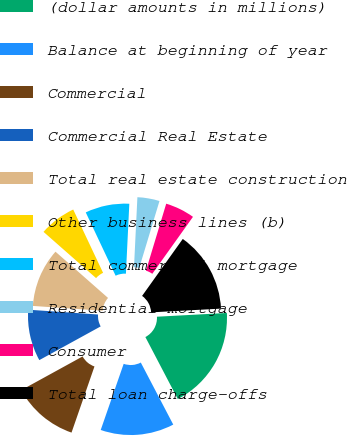Convert chart to OTSL. <chart><loc_0><loc_0><loc_500><loc_500><pie_chart><fcel>(dollar amounts in millions)<fcel>Balance at beginning of year<fcel>Commercial<fcel>Commercial Real Estate<fcel>Total real estate construction<fcel>Other business lines (b)<fcel>Total commercial mortgage<fcel>Residential mortgage<fcel>Consumer<fcel>Total loan charge-offs<nl><fcel>18.18%<fcel>12.99%<fcel>11.69%<fcel>9.09%<fcel>10.39%<fcel>6.5%<fcel>7.79%<fcel>3.9%<fcel>5.2%<fcel>14.28%<nl></chart> 